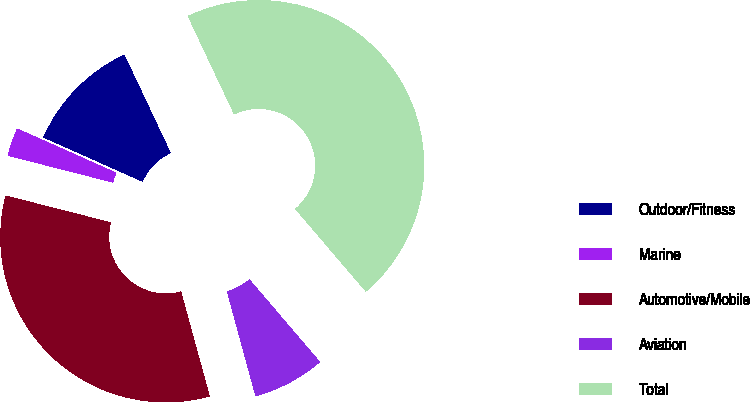Convert chart. <chart><loc_0><loc_0><loc_500><loc_500><pie_chart><fcel>Outdoor/Fitness<fcel>Marine<fcel>Automotive/Mobile<fcel>Aviation<fcel>Total<nl><fcel>11.31%<fcel>2.7%<fcel>33.22%<fcel>7.01%<fcel>45.76%<nl></chart> 